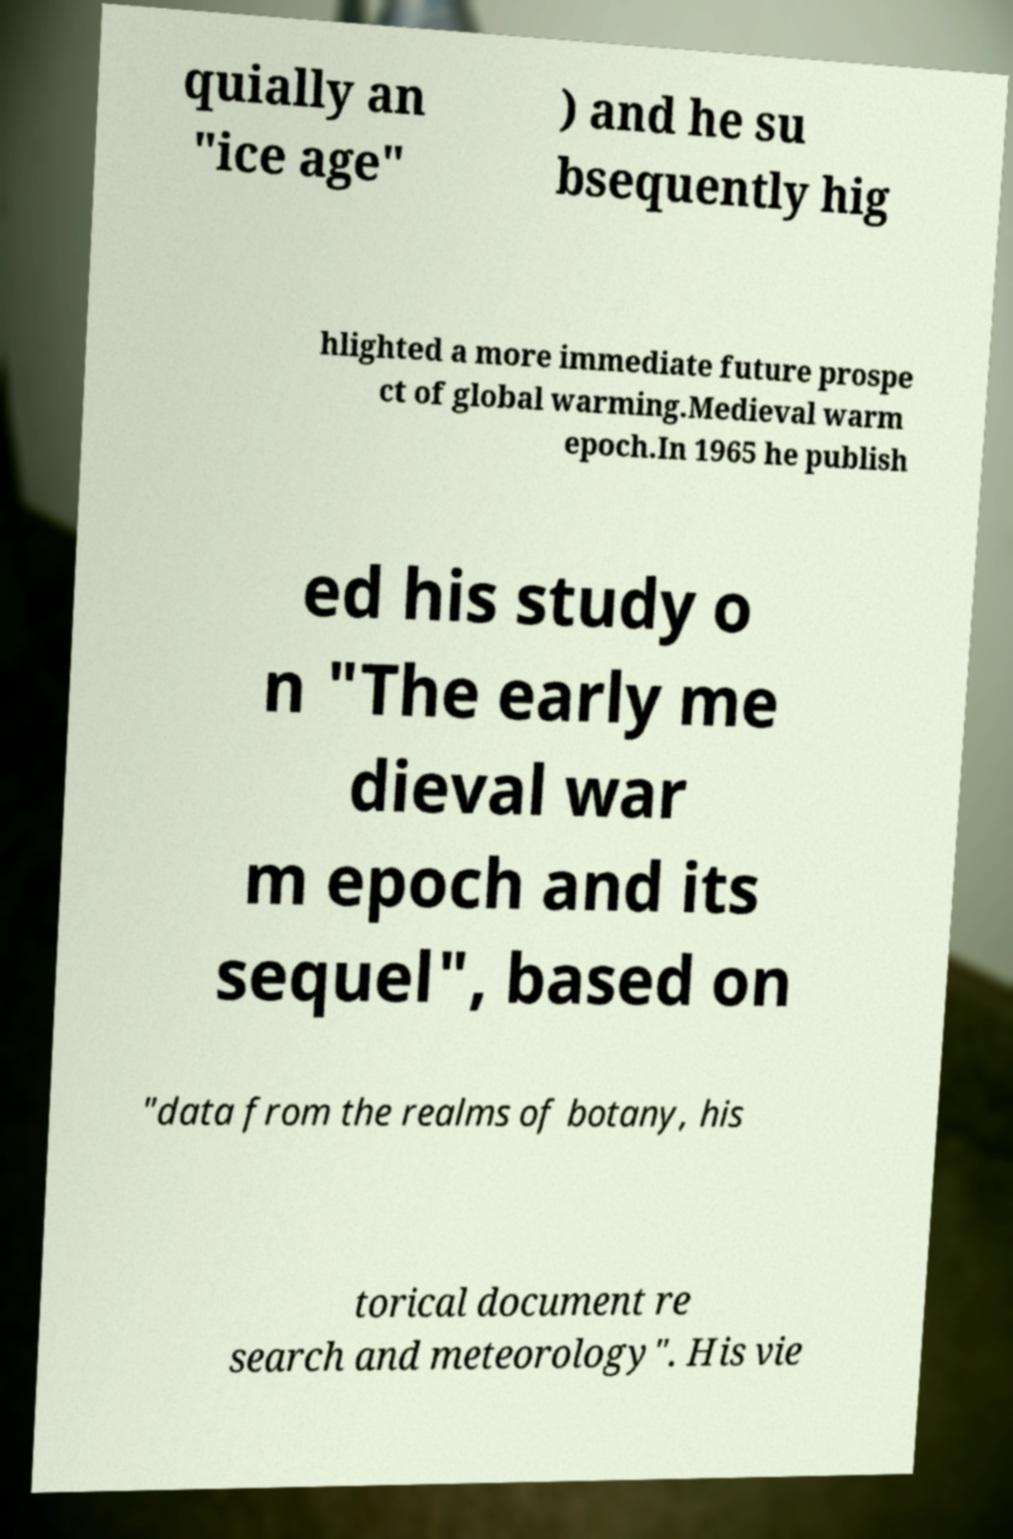Can you read and provide the text displayed in the image?This photo seems to have some interesting text. Can you extract and type it out for me? quially an "ice age" ) and he su bsequently hig hlighted a more immediate future prospe ct of global warming.Medieval warm epoch.In 1965 he publish ed his study o n "The early me dieval war m epoch and its sequel", based on "data from the realms of botany, his torical document re search and meteorology". His vie 